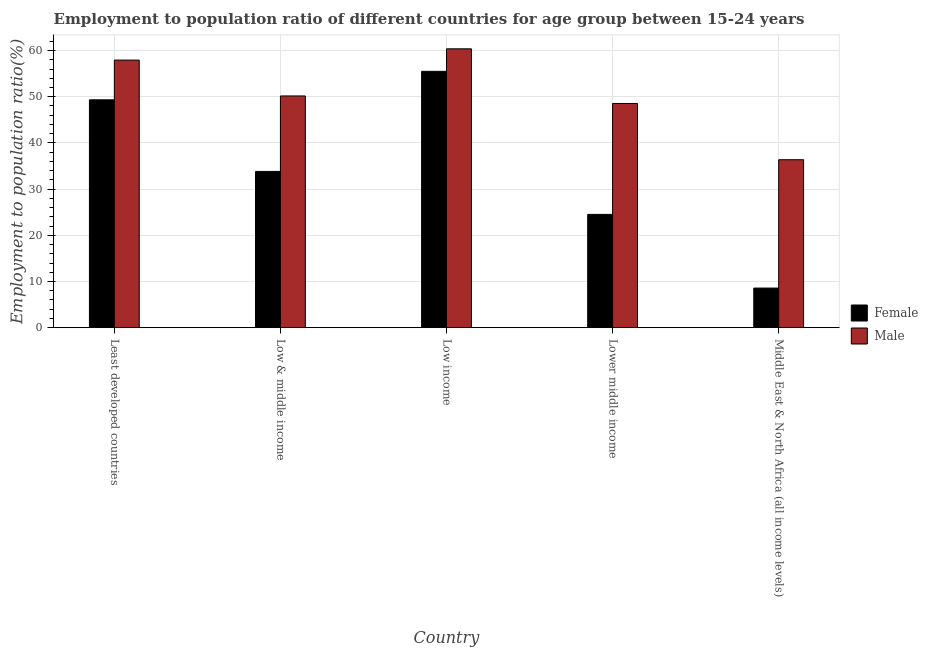How many groups of bars are there?
Give a very brief answer. 5. How many bars are there on the 5th tick from the right?
Ensure brevity in your answer.  2. What is the label of the 2nd group of bars from the left?
Give a very brief answer. Low & middle income. What is the employment to population ratio(female) in Lower middle income?
Provide a succinct answer. 24.53. Across all countries, what is the maximum employment to population ratio(female)?
Your answer should be compact. 55.51. Across all countries, what is the minimum employment to population ratio(male)?
Ensure brevity in your answer.  36.36. In which country was the employment to population ratio(female) minimum?
Keep it short and to the point. Middle East & North Africa (all income levels). What is the total employment to population ratio(female) in the graph?
Offer a terse response. 171.78. What is the difference between the employment to population ratio(female) in Low & middle income and that in Middle East & North Africa (all income levels)?
Offer a very short reply. 25.26. What is the difference between the employment to population ratio(female) in Low income and the employment to population ratio(male) in Middle East & North Africa (all income levels)?
Your answer should be very brief. 19.14. What is the average employment to population ratio(female) per country?
Your answer should be very brief. 34.36. What is the difference between the employment to population ratio(male) and employment to population ratio(female) in Least developed countries?
Provide a short and direct response. 8.6. In how many countries, is the employment to population ratio(male) greater than 12 %?
Offer a very short reply. 5. What is the ratio of the employment to population ratio(female) in Lower middle income to that in Middle East & North Africa (all income levels)?
Offer a terse response. 2.86. Is the employment to population ratio(female) in Least developed countries less than that in Low & middle income?
Keep it short and to the point. No. What is the difference between the highest and the second highest employment to population ratio(male)?
Ensure brevity in your answer.  2.44. What is the difference between the highest and the lowest employment to population ratio(male)?
Your answer should be compact. 24.02. What does the 2nd bar from the right in Low & middle income represents?
Your response must be concise. Female. Are all the bars in the graph horizontal?
Keep it short and to the point. No. How many countries are there in the graph?
Offer a terse response. 5. What is the difference between two consecutive major ticks on the Y-axis?
Ensure brevity in your answer.  10. Where does the legend appear in the graph?
Provide a short and direct response. Center right. What is the title of the graph?
Provide a succinct answer. Employment to population ratio of different countries for age group between 15-24 years. Does "Age 65(female)" appear as one of the legend labels in the graph?
Your response must be concise. No. What is the label or title of the X-axis?
Provide a succinct answer. Country. What is the label or title of the Y-axis?
Keep it short and to the point. Employment to population ratio(%). What is the Employment to population ratio(%) of Female in Least developed countries?
Keep it short and to the point. 49.34. What is the Employment to population ratio(%) in Male in Least developed countries?
Offer a terse response. 57.94. What is the Employment to population ratio(%) of Female in Low & middle income?
Provide a short and direct response. 33.83. What is the Employment to population ratio(%) of Male in Low & middle income?
Give a very brief answer. 50.18. What is the Employment to population ratio(%) of Female in Low income?
Your answer should be compact. 55.51. What is the Employment to population ratio(%) in Male in Low income?
Provide a succinct answer. 60.38. What is the Employment to population ratio(%) in Female in Lower middle income?
Offer a very short reply. 24.53. What is the Employment to population ratio(%) of Male in Lower middle income?
Your answer should be compact. 48.55. What is the Employment to population ratio(%) in Female in Middle East & North Africa (all income levels)?
Offer a very short reply. 8.57. What is the Employment to population ratio(%) of Male in Middle East & North Africa (all income levels)?
Make the answer very short. 36.36. Across all countries, what is the maximum Employment to population ratio(%) of Female?
Ensure brevity in your answer.  55.51. Across all countries, what is the maximum Employment to population ratio(%) of Male?
Provide a short and direct response. 60.38. Across all countries, what is the minimum Employment to population ratio(%) in Female?
Make the answer very short. 8.57. Across all countries, what is the minimum Employment to population ratio(%) of Male?
Keep it short and to the point. 36.36. What is the total Employment to population ratio(%) of Female in the graph?
Offer a very short reply. 171.78. What is the total Employment to population ratio(%) in Male in the graph?
Your answer should be compact. 253.42. What is the difference between the Employment to population ratio(%) in Female in Least developed countries and that in Low & middle income?
Ensure brevity in your answer.  15.51. What is the difference between the Employment to population ratio(%) in Male in Least developed countries and that in Low & middle income?
Your answer should be compact. 7.77. What is the difference between the Employment to population ratio(%) of Female in Least developed countries and that in Low income?
Your answer should be very brief. -6.17. What is the difference between the Employment to population ratio(%) of Male in Least developed countries and that in Low income?
Offer a very short reply. -2.44. What is the difference between the Employment to population ratio(%) of Female in Least developed countries and that in Lower middle income?
Give a very brief answer. 24.81. What is the difference between the Employment to population ratio(%) of Male in Least developed countries and that in Lower middle income?
Offer a terse response. 9.39. What is the difference between the Employment to population ratio(%) in Female in Least developed countries and that in Middle East & North Africa (all income levels)?
Offer a terse response. 40.77. What is the difference between the Employment to population ratio(%) in Male in Least developed countries and that in Middle East & North Africa (all income levels)?
Keep it short and to the point. 21.58. What is the difference between the Employment to population ratio(%) in Female in Low & middle income and that in Low income?
Provide a succinct answer. -21.68. What is the difference between the Employment to population ratio(%) in Male in Low & middle income and that in Low income?
Offer a very short reply. -10.2. What is the difference between the Employment to population ratio(%) of Female in Low & middle income and that in Lower middle income?
Keep it short and to the point. 9.3. What is the difference between the Employment to population ratio(%) in Male in Low & middle income and that in Lower middle income?
Provide a short and direct response. 1.63. What is the difference between the Employment to population ratio(%) in Female in Low & middle income and that in Middle East & North Africa (all income levels)?
Your answer should be compact. 25.26. What is the difference between the Employment to population ratio(%) of Male in Low & middle income and that in Middle East & North Africa (all income levels)?
Provide a succinct answer. 13.81. What is the difference between the Employment to population ratio(%) in Female in Low income and that in Lower middle income?
Ensure brevity in your answer.  30.98. What is the difference between the Employment to population ratio(%) of Male in Low income and that in Lower middle income?
Your answer should be very brief. 11.83. What is the difference between the Employment to population ratio(%) in Female in Low income and that in Middle East & North Africa (all income levels)?
Offer a terse response. 46.94. What is the difference between the Employment to population ratio(%) in Male in Low income and that in Middle East & North Africa (all income levels)?
Provide a short and direct response. 24.02. What is the difference between the Employment to population ratio(%) in Female in Lower middle income and that in Middle East & North Africa (all income levels)?
Offer a terse response. 15.96. What is the difference between the Employment to population ratio(%) in Male in Lower middle income and that in Middle East & North Africa (all income levels)?
Provide a short and direct response. 12.18. What is the difference between the Employment to population ratio(%) in Female in Least developed countries and the Employment to population ratio(%) in Male in Low & middle income?
Provide a succinct answer. -0.84. What is the difference between the Employment to population ratio(%) of Female in Least developed countries and the Employment to population ratio(%) of Male in Low income?
Offer a very short reply. -11.04. What is the difference between the Employment to population ratio(%) of Female in Least developed countries and the Employment to population ratio(%) of Male in Lower middle income?
Ensure brevity in your answer.  0.79. What is the difference between the Employment to population ratio(%) in Female in Least developed countries and the Employment to population ratio(%) in Male in Middle East & North Africa (all income levels)?
Give a very brief answer. 12.98. What is the difference between the Employment to population ratio(%) in Female in Low & middle income and the Employment to population ratio(%) in Male in Low income?
Offer a terse response. -26.55. What is the difference between the Employment to population ratio(%) in Female in Low & middle income and the Employment to population ratio(%) in Male in Lower middle income?
Make the answer very short. -14.72. What is the difference between the Employment to population ratio(%) of Female in Low & middle income and the Employment to population ratio(%) of Male in Middle East & North Africa (all income levels)?
Provide a succinct answer. -2.53. What is the difference between the Employment to population ratio(%) in Female in Low income and the Employment to population ratio(%) in Male in Lower middle income?
Make the answer very short. 6.96. What is the difference between the Employment to population ratio(%) in Female in Low income and the Employment to population ratio(%) in Male in Middle East & North Africa (all income levels)?
Your answer should be very brief. 19.14. What is the difference between the Employment to population ratio(%) in Female in Lower middle income and the Employment to population ratio(%) in Male in Middle East & North Africa (all income levels)?
Your answer should be compact. -11.84. What is the average Employment to population ratio(%) of Female per country?
Offer a very short reply. 34.36. What is the average Employment to population ratio(%) of Male per country?
Give a very brief answer. 50.68. What is the difference between the Employment to population ratio(%) of Female and Employment to population ratio(%) of Male in Least developed countries?
Your answer should be very brief. -8.6. What is the difference between the Employment to population ratio(%) of Female and Employment to population ratio(%) of Male in Low & middle income?
Provide a succinct answer. -16.34. What is the difference between the Employment to population ratio(%) in Female and Employment to population ratio(%) in Male in Low income?
Provide a succinct answer. -4.87. What is the difference between the Employment to population ratio(%) in Female and Employment to population ratio(%) in Male in Lower middle income?
Offer a very short reply. -24.02. What is the difference between the Employment to population ratio(%) in Female and Employment to population ratio(%) in Male in Middle East & North Africa (all income levels)?
Ensure brevity in your answer.  -27.79. What is the ratio of the Employment to population ratio(%) in Female in Least developed countries to that in Low & middle income?
Provide a succinct answer. 1.46. What is the ratio of the Employment to population ratio(%) of Male in Least developed countries to that in Low & middle income?
Offer a very short reply. 1.15. What is the ratio of the Employment to population ratio(%) in Female in Least developed countries to that in Low income?
Provide a short and direct response. 0.89. What is the ratio of the Employment to population ratio(%) in Male in Least developed countries to that in Low income?
Make the answer very short. 0.96. What is the ratio of the Employment to population ratio(%) in Female in Least developed countries to that in Lower middle income?
Provide a succinct answer. 2.01. What is the ratio of the Employment to population ratio(%) in Male in Least developed countries to that in Lower middle income?
Provide a short and direct response. 1.19. What is the ratio of the Employment to population ratio(%) in Female in Least developed countries to that in Middle East & North Africa (all income levels)?
Make the answer very short. 5.76. What is the ratio of the Employment to population ratio(%) of Male in Least developed countries to that in Middle East & North Africa (all income levels)?
Your answer should be compact. 1.59. What is the ratio of the Employment to population ratio(%) in Female in Low & middle income to that in Low income?
Make the answer very short. 0.61. What is the ratio of the Employment to population ratio(%) of Male in Low & middle income to that in Low income?
Keep it short and to the point. 0.83. What is the ratio of the Employment to population ratio(%) in Female in Low & middle income to that in Lower middle income?
Offer a very short reply. 1.38. What is the ratio of the Employment to population ratio(%) in Male in Low & middle income to that in Lower middle income?
Offer a very short reply. 1.03. What is the ratio of the Employment to population ratio(%) in Female in Low & middle income to that in Middle East & North Africa (all income levels)?
Provide a short and direct response. 3.95. What is the ratio of the Employment to population ratio(%) in Male in Low & middle income to that in Middle East & North Africa (all income levels)?
Make the answer very short. 1.38. What is the ratio of the Employment to population ratio(%) in Female in Low income to that in Lower middle income?
Ensure brevity in your answer.  2.26. What is the ratio of the Employment to population ratio(%) in Male in Low income to that in Lower middle income?
Your answer should be compact. 1.24. What is the ratio of the Employment to population ratio(%) of Female in Low income to that in Middle East & North Africa (all income levels)?
Offer a very short reply. 6.48. What is the ratio of the Employment to population ratio(%) of Male in Low income to that in Middle East & North Africa (all income levels)?
Make the answer very short. 1.66. What is the ratio of the Employment to population ratio(%) of Female in Lower middle income to that in Middle East & North Africa (all income levels)?
Provide a short and direct response. 2.86. What is the ratio of the Employment to population ratio(%) of Male in Lower middle income to that in Middle East & North Africa (all income levels)?
Your answer should be compact. 1.34. What is the difference between the highest and the second highest Employment to population ratio(%) in Female?
Provide a short and direct response. 6.17. What is the difference between the highest and the second highest Employment to population ratio(%) in Male?
Your answer should be compact. 2.44. What is the difference between the highest and the lowest Employment to population ratio(%) of Female?
Keep it short and to the point. 46.94. What is the difference between the highest and the lowest Employment to population ratio(%) in Male?
Ensure brevity in your answer.  24.02. 